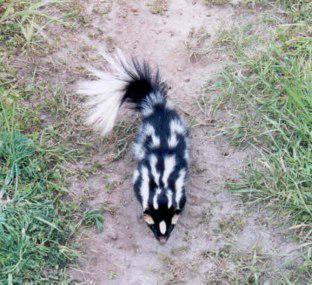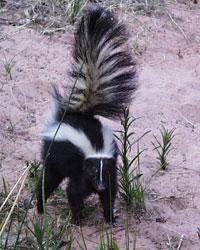The first image is the image on the left, the second image is the image on the right. Given the left and right images, does the statement "There is a skunk outside in the center of both images." hold true? Answer yes or no. Yes. The first image is the image on the left, the second image is the image on the right. Analyze the images presented: Is the assertion "One image contains a spotted skunk with its face down and its tail somewhat curled, and the other image contains one skunk with bold white stripe, which is standing on all fours." valid? Answer yes or no. Yes. 